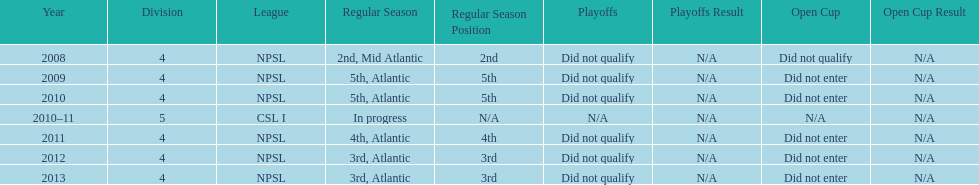What is the lowest place they came in 5th. 